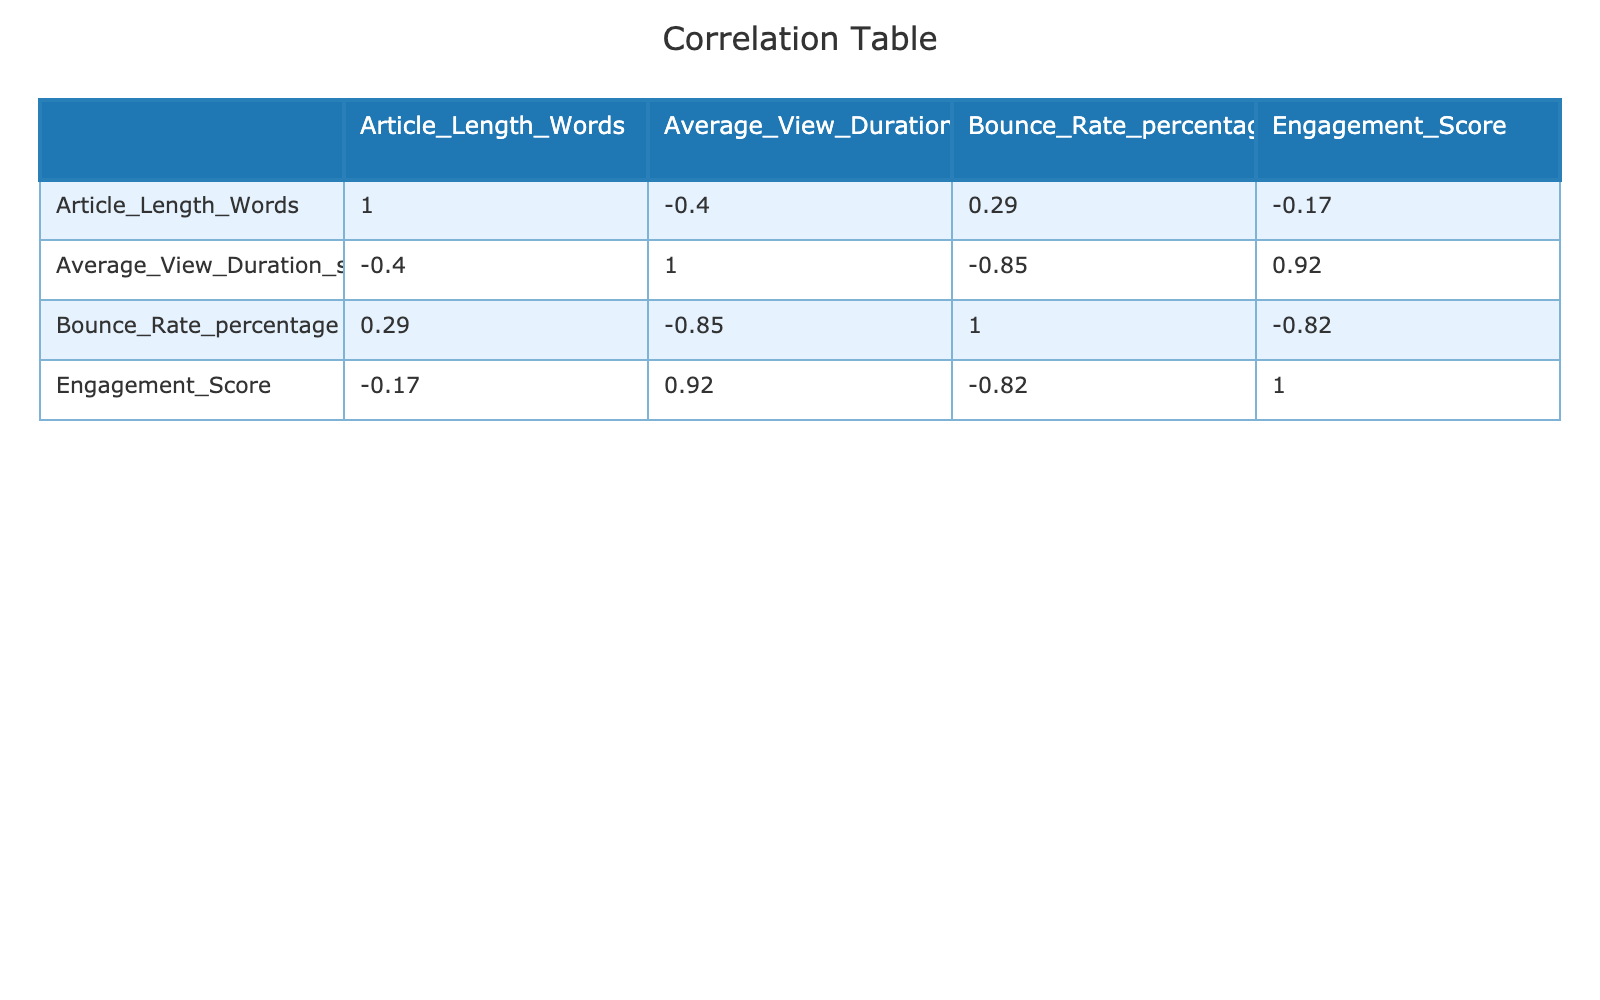What is the bounce rate for the article titled "Health Benefits of a Plant-Based Diet"? The bounce rate for “Health Benefits of a Plant-Based Diet” can be found in the row corresponding to that article. Its bounce rate is listed as 28%.
Answer: 28% Which article has the highest engagement score? To find the article with the highest engagement score, we compare the engagement scores across all articles. The article "Health Benefits of a Plant-Based Diet" has the highest score at 88.
Answer: Health Benefits of a Plant-Based Diet What is the average article length for articles with an average view duration greater than 400 seconds? First, we filter the articles with an average view duration exceeding 400 seconds. The relevant articles ("New Advancements in AI Technology", "10 Tips for Effective Online Learning", and "Traveling Post-Pandemic: Tips and Tricks") have lengths of 850, 900, and 800 words respectively. The average length is (850 + 900 + 800) / 3 = 850.
Answer: 850 Is there a correlation between article length and bounce rate? To determine if there's a correlation, we look at the correlation coefficient between article length and bounce rate in the table. A negative correlation value indicates an inverse relationship, which suggests that as article length increases, the bounce rate may decrease or vice versa. In this case, the correlation coefficient is negative (-0.38), indicating a moderate inverse relationship.
Answer: Yes What is the engagement score for the article "Breaking News: Major Political Developments"? By locating the row for "Breaking News: Major Political Developments" in the table, we find its engagement score is 65.
Answer: 65 Which article has both the lowest average view duration and the highest bounce rate? We need to compare the average view duration and bounce rate across all articles. By reviewing the table, “Breaking News: Major Political Developments” has the lowest average view duration of 240 seconds and the highest bounce rate of 55%.
Answer: Breaking News: Major Political Developments What is the difference in average view duration between articles with engagement scores over 80 and those under 80? First, we identify articles with engagement scores over 80 ("New Advancements in AI Technology", "10 Tips for Effective Online Learning", "Health Benefits of a Plant-Based Diet", "Traveling Post-Pandemic: Tips and Tricks"), which have average view durations of 450, 600, 530, and 560 seconds respectively. Their average view duration is (450 + 600 + 530 + 560) / 4 = 535 seconds. The second group has articles with scores below 80 ("Climate Change and Its Global Impact", "The Rise of Renewable Energy Sources", "Understanding Cryptocurrency Basics", "Exploring the Universe: The Latest in Astronomy", "Tech Innovations to Watch in 2024"), averaging (300 + 280 + 400 + 320 + 350) / 5 = 330 seconds. The difference is 535 - 330 = 205 seconds.
Answer: 205 seconds 